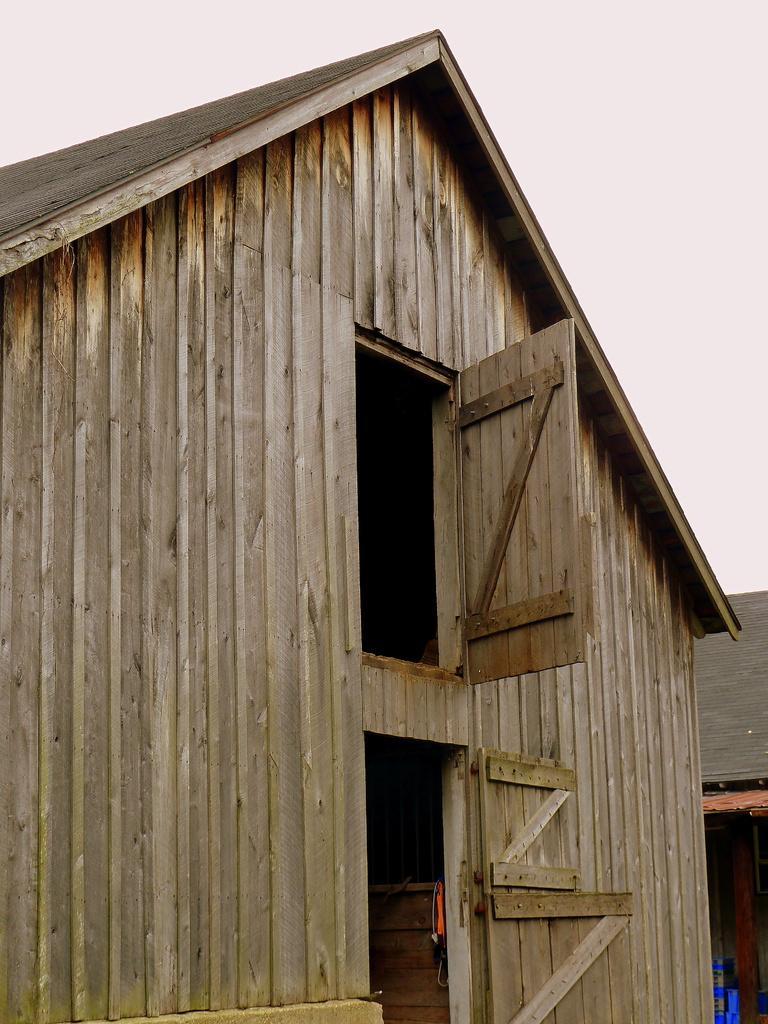Could you give a brief overview of what you see in this image? In this image I can see few shacks and here I can see an orange colour thing. I can also see few blue things in the background and here I can see doors. 